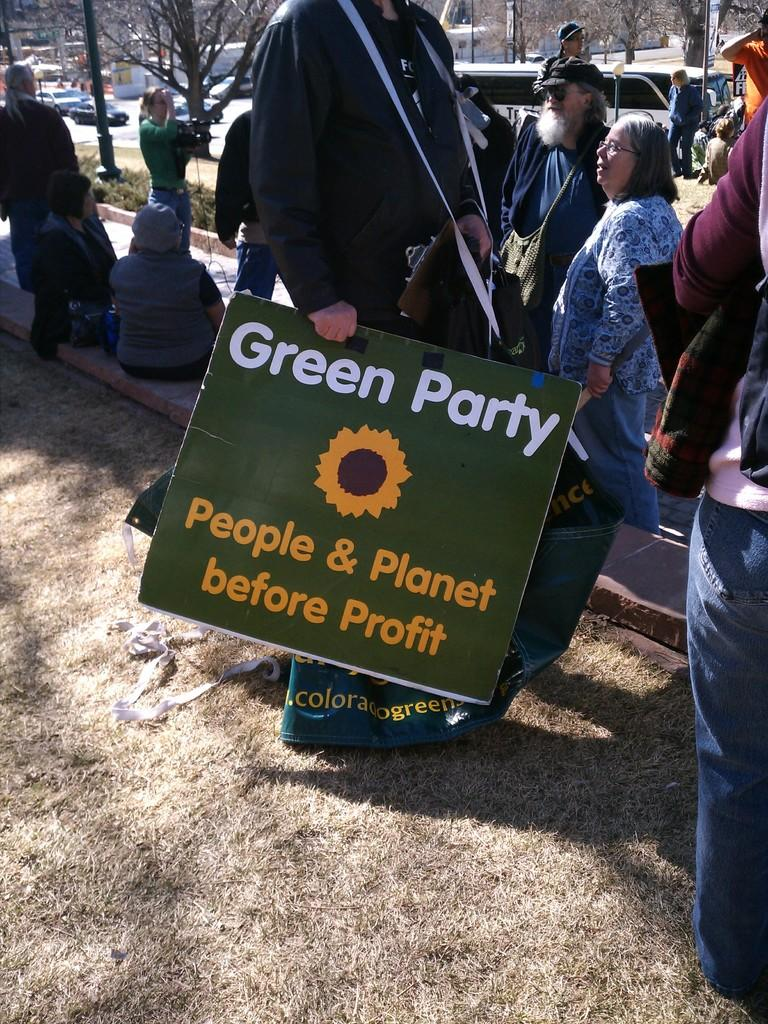What is the person in the image holding? The person is holding a board in the image. What type of natural environment is visible in the image? There are trees and plants in the image, indicating a natural environment. How many people are present in the image? There are people in the image, but the exact number is not specified. What type of man-made objects can be seen in the image? There are vehicles in the image. Can you see any cattle grazing in the image? No, there are no cattle present in the image. 